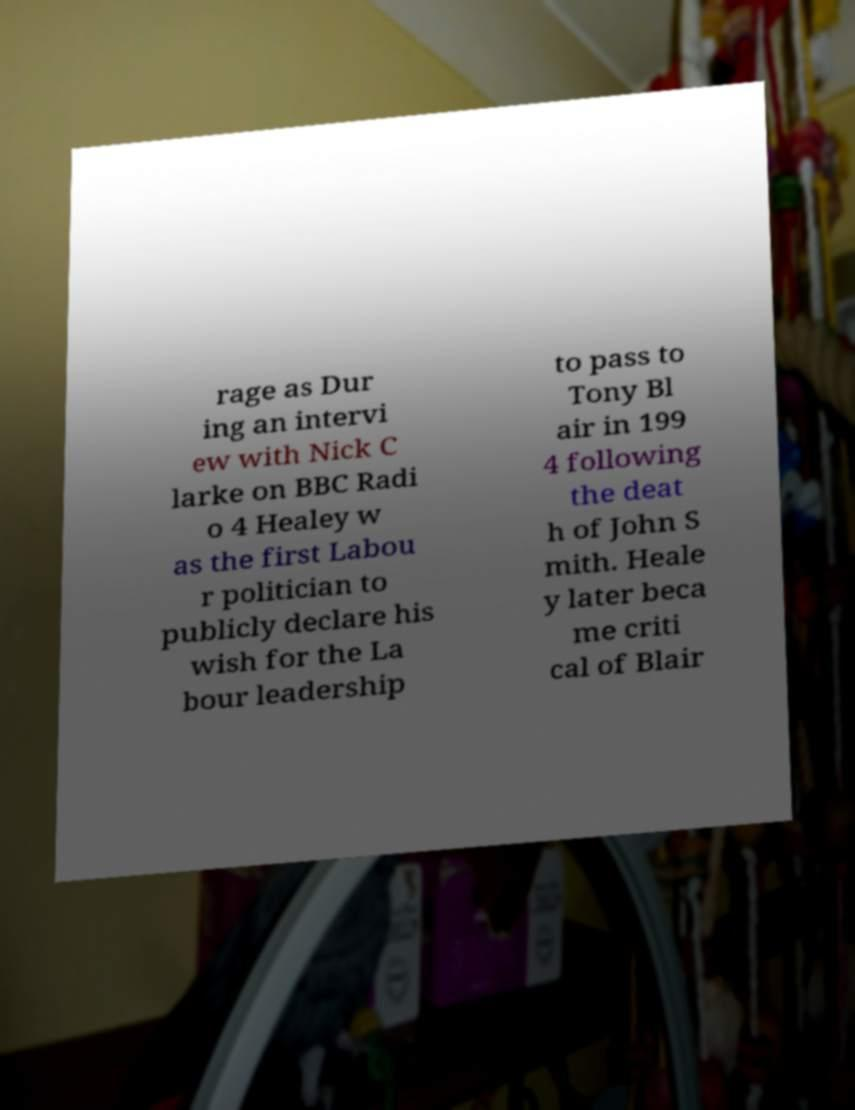There's text embedded in this image that I need extracted. Can you transcribe it verbatim? rage as Dur ing an intervi ew with Nick C larke on BBC Radi o 4 Healey w as the first Labou r politician to publicly declare his wish for the La bour leadership to pass to Tony Bl air in 199 4 following the deat h of John S mith. Heale y later beca me criti cal of Blair 